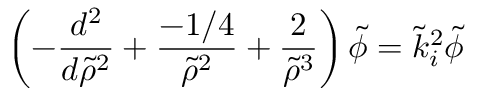Convert formula to latex. <formula><loc_0><loc_0><loc_500><loc_500>\left ( - \frac { d ^ { 2 } } { d \tilde { \rho } ^ { 2 } } + \frac { - 1 / 4 } { \tilde { \rho } ^ { 2 } } + \frac { 2 } { \tilde { \rho } ^ { 3 } } \right ) \tilde { \phi } = \tilde { k } _ { i } ^ { 2 } \tilde { \phi }</formula> 